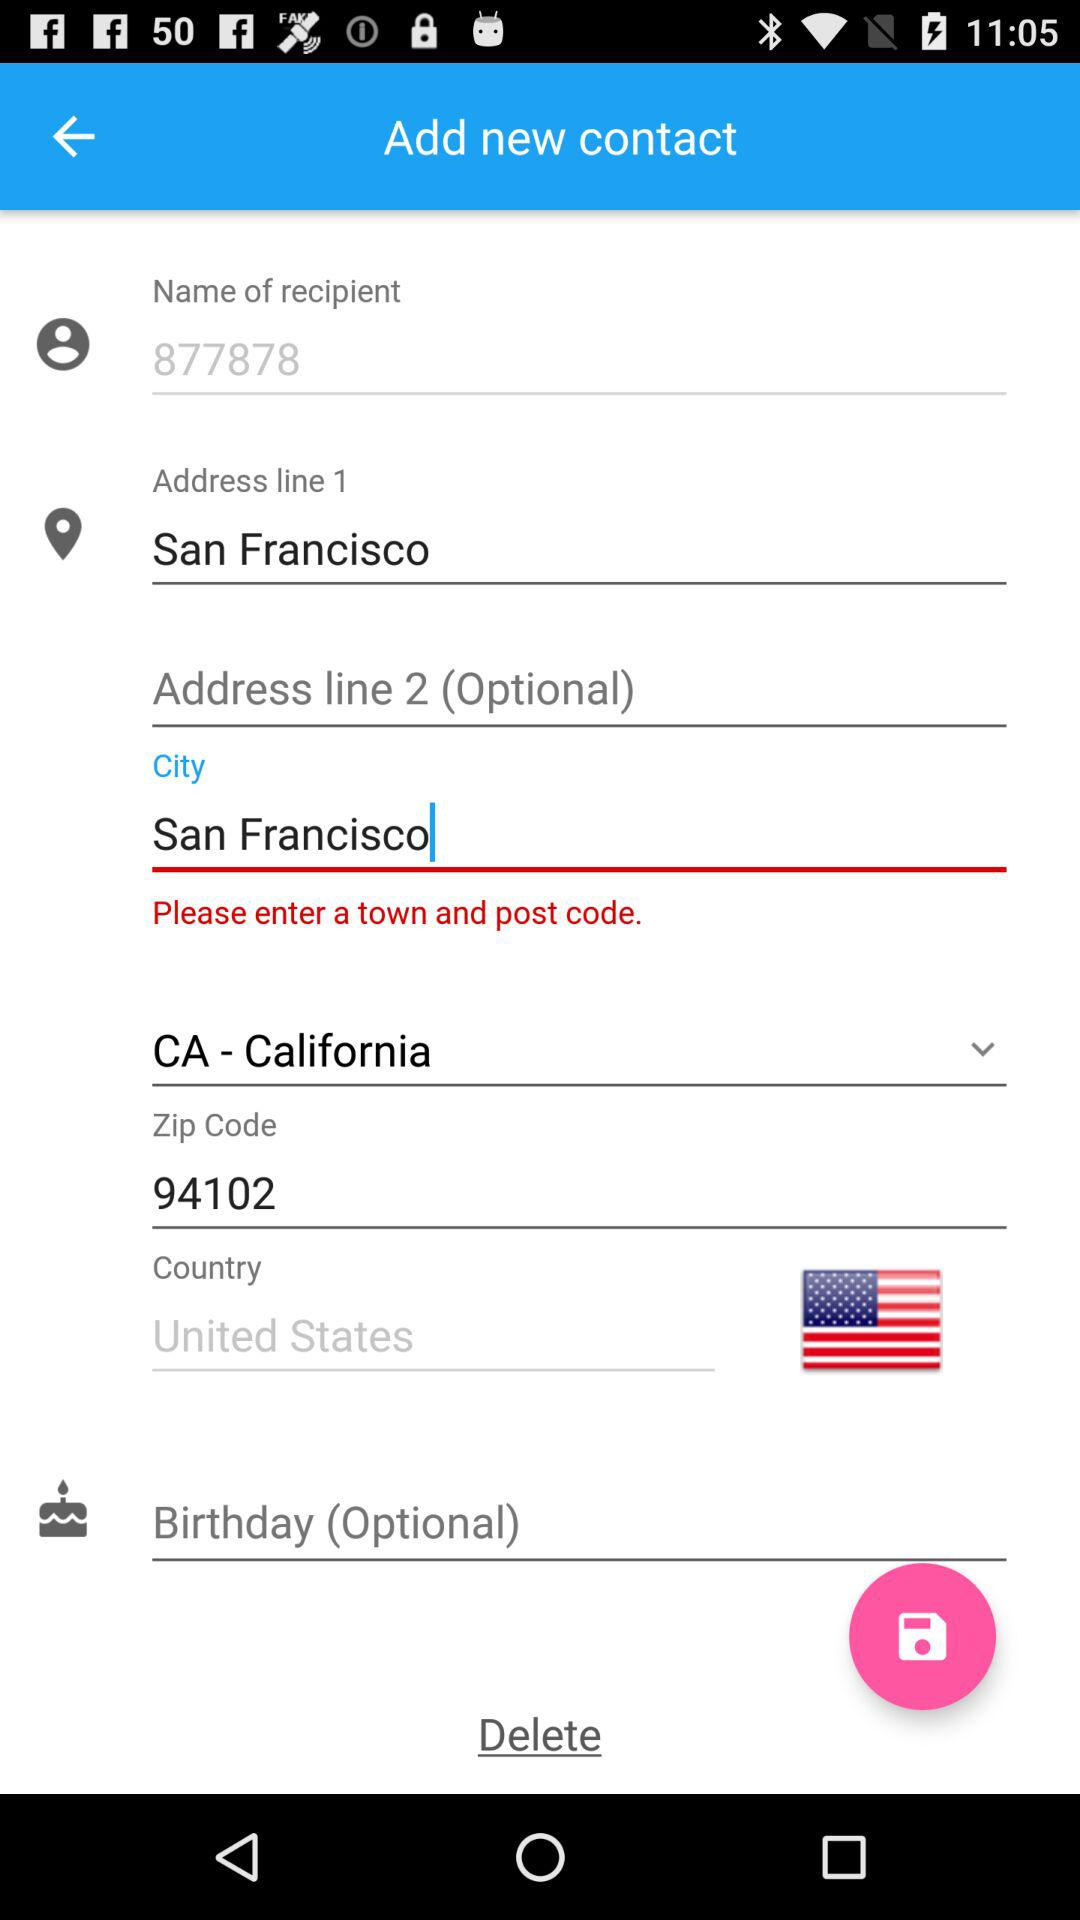What is the phone number?
When the provided information is insufficient, respond with <no answer>. <no answer> 